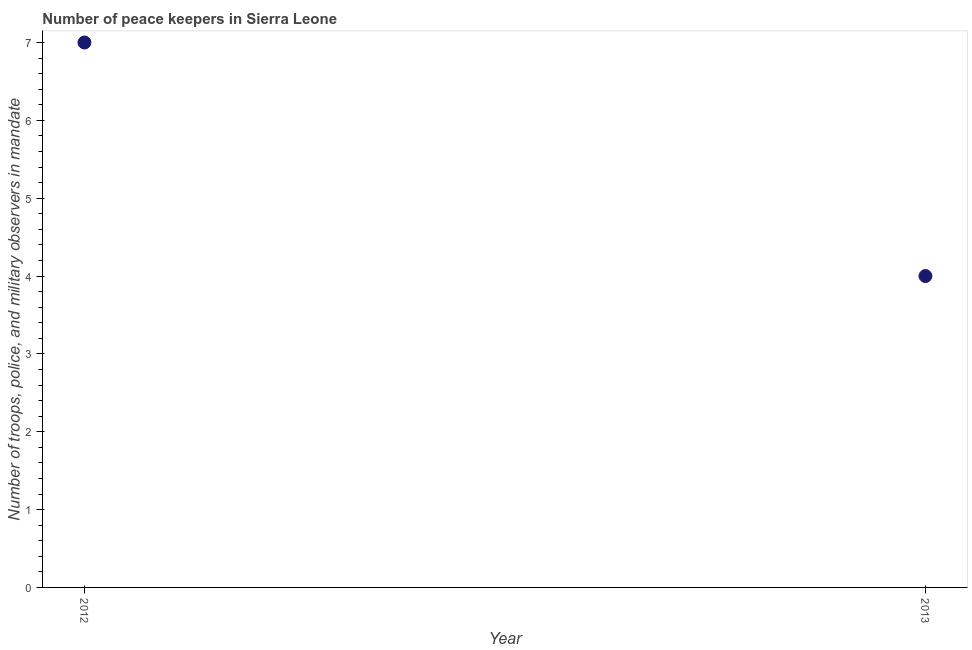What is the number of peace keepers in 2012?
Your answer should be compact. 7. Across all years, what is the maximum number of peace keepers?
Provide a short and direct response. 7. Across all years, what is the minimum number of peace keepers?
Offer a very short reply. 4. What is the sum of the number of peace keepers?
Your response must be concise. 11. What is the difference between the number of peace keepers in 2012 and 2013?
Give a very brief answer. 3. In how many years, is the number of peace keepers greater than the average number of peace keepers taken over all years?
Offer a very short reply. 1. How many dotlines are there?
Offer a very short reply. 1. What is the difference between two consecutive major ticks on the Y-axis?
Ensure brevity in your answer.  1. Are the values on the major ticks of Y-axis written in scientific E-notation?
Give a very brief answer. No. Does the graph contain any zero values?
Provide a succinct answer. No. What is the title of the graph?
Your response must be concise. Number of peace keepers in Sierra Leone. What is the label or title of the Y-axis?
Provide a short and direct response. Number of troops, police, and military observers in mandate. What is the Number of troops, police, and military observers in mandate in 2012?
Provide a succinct answer. 7. What is the Number of troops, police, and military observers in mandate in 2013?
Make the answer very short. 4. What is the difference between the Number of troops, police, and military observers in mandate in 2012 and 2013?
Your response must be concise. 3. What is the ratio of the Number of troops, police, and military observers in mandate in 2012 to that in 2013?
Offer a very short reply. 1.75. 